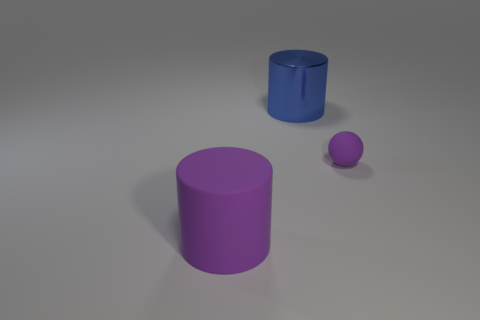Add 2 small yellow balls. How many objects exist? 5 Subtract all cylinders. How many objects are left? 1 Subtract all big green matte cubes. Subtract all small balls. How many objects are left? 2 Add 1 purple cylinders. How many purple cylinders are left? 2 Add 3 big purple rubber blocks. How many big purple rubber blocks exist? 3 Subtract 0 red cubes. How many objects are left? 3 